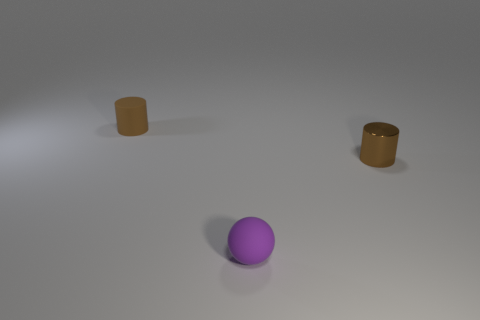Could you describe the spatial arrangement between the objects? Certainly! The image shows a purple sphere centrally positioned in the foreground. Two cylinders are placed in the background, spaced apart from each other. There's an ample amount of space between all three objects, so the layout feels uncrowded. The arrangement might suggest deliberate positioning, possibly for an artistic composition or a visual study of geometry and materials. 